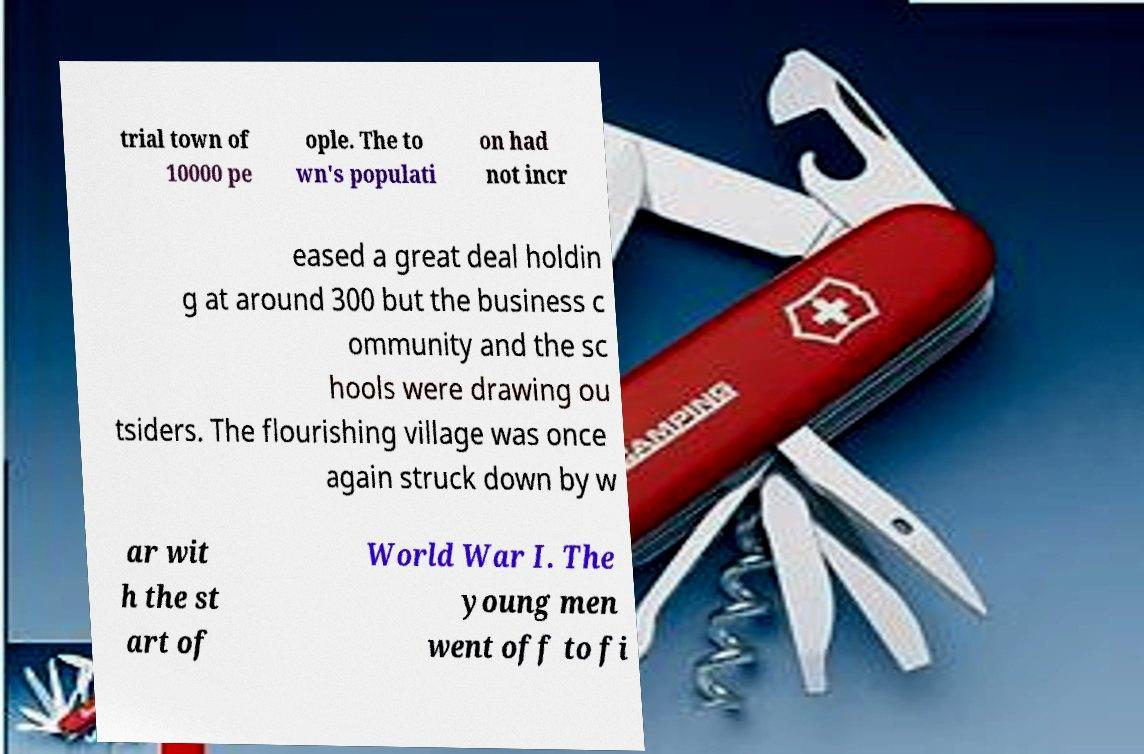Please identify and transcribe the text found in this image. trial town of 10000 pe ople. The to wn's populati on had not incr eased a great deal holdin g at around 300 but the business c ommunity and the sc hools were drawing ou tsiders. The flourishing village was once again struck down by w ar wit h the st art of World War I. The young men went off to fi 